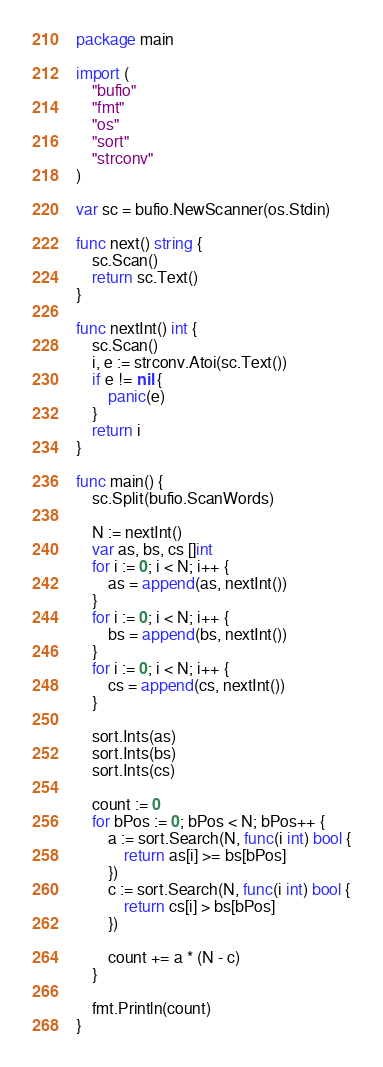Convert code to text. <code><loc_0><loc_0><loc_500><loc_500><_Go_>package main

import (
	"bufio"
	"fmt"
	"os"
	"sort"
	"strconv"
)

var sc = bufio.NewScanner(os.Stdin)

func next() string {
	sc.Scan()
	return sc.Text()
}

func nextInt() int {
	sc.Scan()
	i, e := strconv.Atoi(sc.Text())
	if e != nil {
		panic(e)
	}
	return i
}

func main() {
	sc.Split(bufio.ScanWords)

	N := nextInt()
	var as, bs, cs []int
	for i := 0; i < N; i++ {
		as = append(as, nextInt())
	}
	for i := 0; i < N; i++ {
		bs = append(bs, nextInt())
	}
	for i := 0; i < N; i++ {
		cs = append(cs, nextInt())
	}

	sort.Ints(as)
	sort.Ints(bs)
	sort.Ints(cs)

	count := 0
	for bPos := 0; bPos < N; bPos++ {
		a := sort.Search(N, func(i int) bool {
			return as[i] >= bs[bPos]
		})
		c := sort.Search(N, func(i int) bool {
			return cs[i] > bs[bPos]
		})
		
		count += a * (N - c)
	}

	fmt.Println(count)
}
</code> 